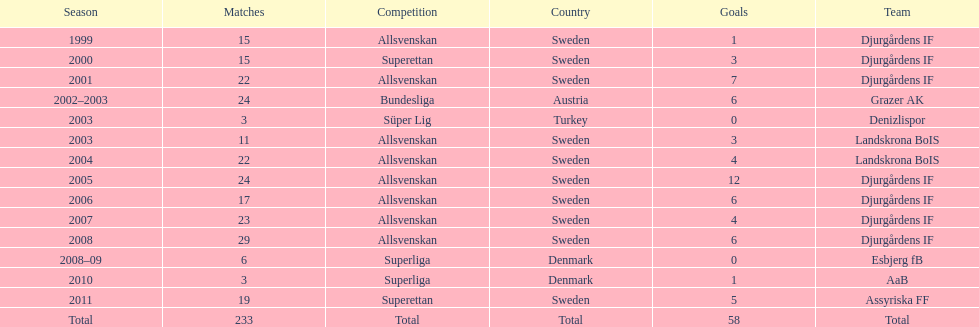In his initial season, how many contests did jones kusi-asare take part in? 15. 